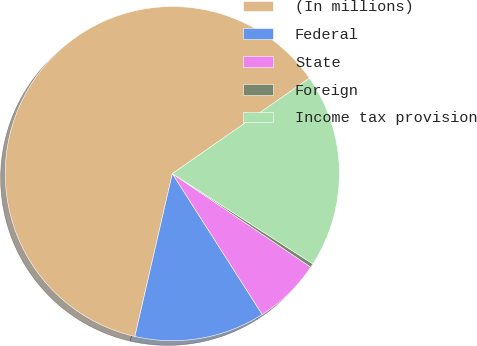Convert chart to OTSL. <chart><loc_0><loc_0><loc_500><loc_500><pie_chart><fcel>(In millions)<fcel>Federal<fcel>State<fcel>Foreign<fcel>Income tax provision<nl><fcel>61.72%<fcel>12.64%<fcel>6.5%<fcel>0.37%<fcel>18.77%<nl></chart> 